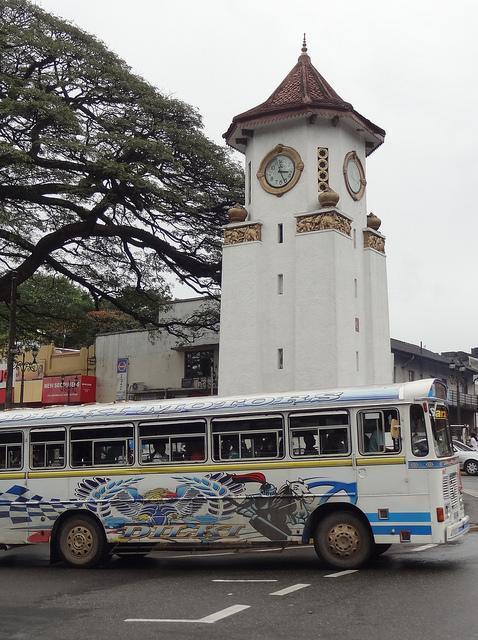How many people are wearing orange shirts?
Give a very brief answer. 0. 